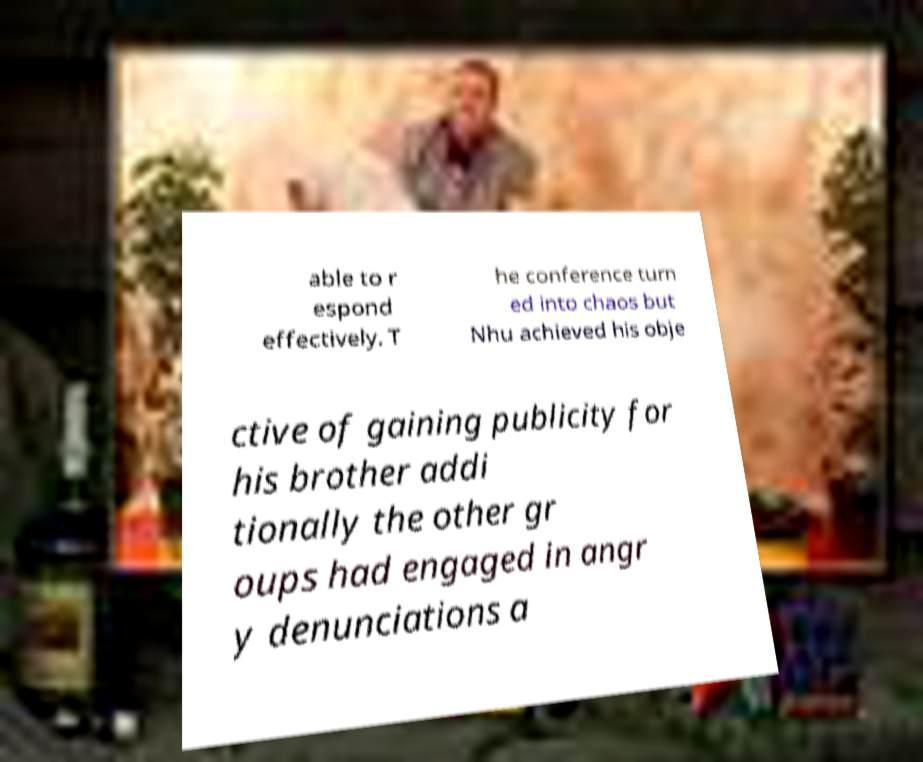Can you read and provide the text displayed in the image?This photo seems to have some interesting text. Can you extract and type it out for me? able to r espond effectively. T he conference turn ed into chaos but Nhu achieved his obje ctive of gaining publicity for his brother addi tionally the other gr oups had engaged in angr y denunciations a 